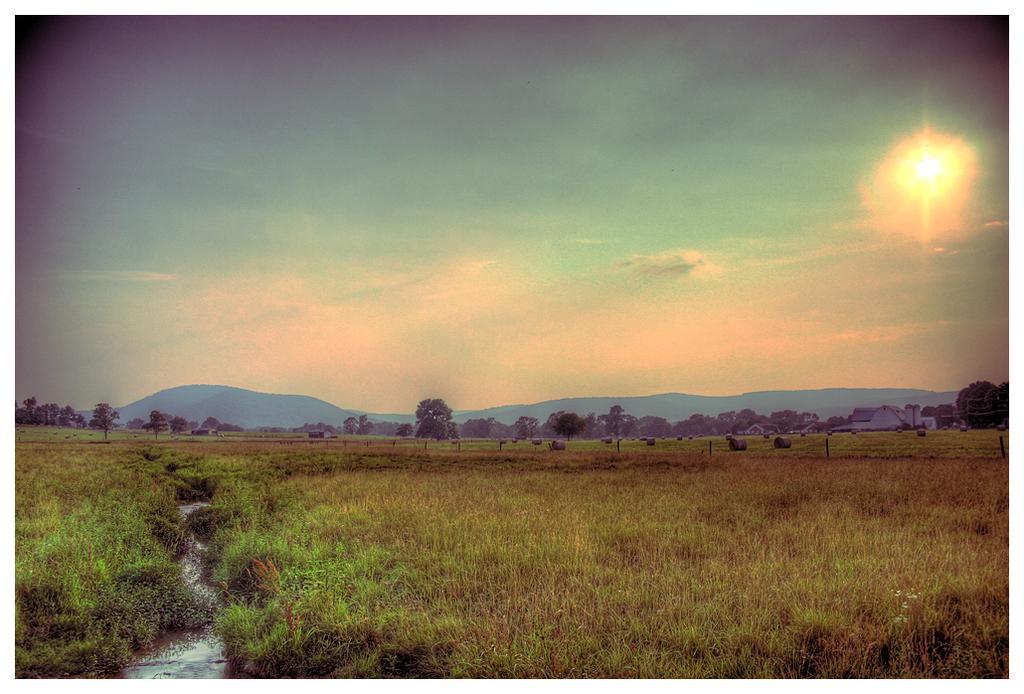In one or two sentences, can you explain what this image depicts? In this image, we can see a crop. There are trees and hills in the middle of the image. There is a sun in the sky. 